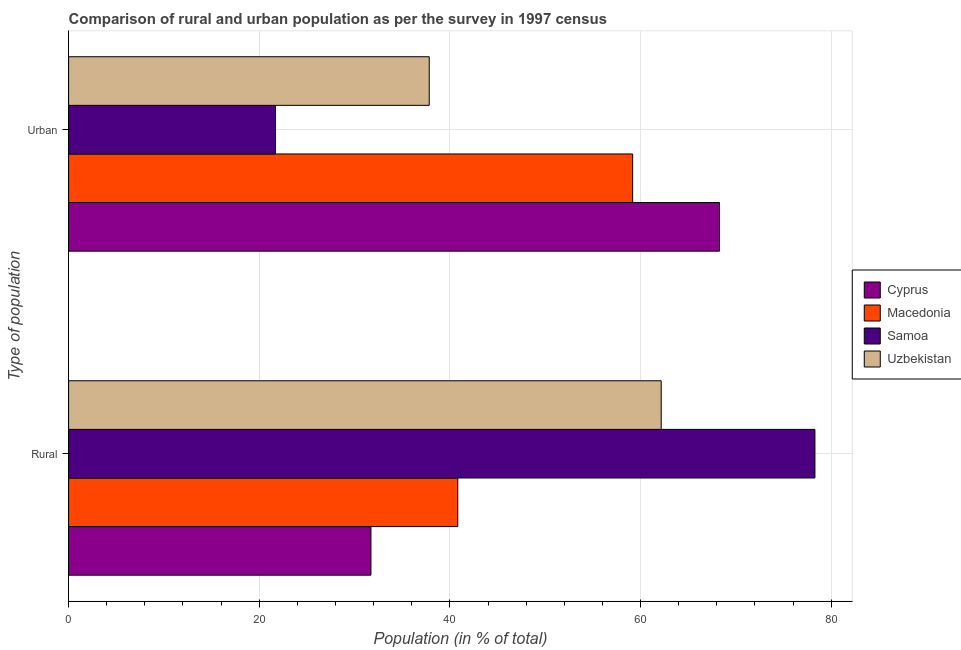How many groups of bars are there?
Keep it short and to the point. 2. What is the label of the 2nd group of bars from the top?
Ensure brevity in your answer.  Rural. What is the urban population in Macedonia?
Offer a terse response. 59.17. Across all countries, what is the maximum urban population?
Ensure brevity in your answer.  68.28. Across all countries, what is the minimum urban population?
Your response must be concise. 21.7. In which country was the urban population maximum?
Provide a short and direct response. Cyprus. In which country was the rural population minimum?
Your response must be concise. Cyprus. What is the total urban population in the graph?
Provide a short and direct response. 186.99. What is the difference between the urban population in Uzbekistan and that in Macedonia?
Give a very brief answer. -21.34. What is the difference between the rural population in Samoa and the urban population in Uzbekistan?
Keep it short and to the point. 40.46. What is the average urban population per country?
Provide a short and direct response. 46.75. What is the difference between the urban population and rural population in Samoa?
Provide a succinct answer. -56.59. In how many countries, is the rural population greater than 68 %?
Make the answer very short. 1. What is the ratio of the rural population in Uzbekistan to that in Samoa?
Your response must be concise. 0.79. What does the 3rd bar from the top in Urban represents?
Your response must be concise. Macedonia. What does the 4th bar from the bottom in Rural represents?
Offer a very short reply. Uzbekistan. How many countries are there in the graph?
Provide a short and direct response. 4. What is the difference between two consecutive major ticks on the X-axis?
Your answer should be very brief. 20. Are the values on the major ticks of X-axis written in scientific E-notation?
Provide a succinct answer. No. Does the graph contain grids?
Offer a terse response. Yes. Where does the legend appear in the graph?
Your response must be concise. Center right. How many legend labels are there?
Your response must be concise. 4. What is the title of the graph?
Ensure brevity in your answer.  Comparison of rural and urban population as per the survey in 1997 census. What is the label or title of the X-axis?
Offer a terse response. Population (in % of total). What is the label or title of the Y-axis?
Offer a very short reply. Type of population. What is the Population (in % of total) in Cyprus in Rural?
Ensure brevity in your answer.  31.72. What is the Population (in % of total) of Macedonia in Rural?
Your response must be concise. 40.83. What is the Population (in % of total) of Samoa in Rural?
Offer a terse response. 78.3. What is the Population (in % of total) in Uzbekistan in Rural?
Make the answer very short. 62.17. What is the Population (in % of total) in Cyprus in Urban?
Provide a succinct answer. 68.28. What is the Population (in % of total) in Macedonia in Urban?
Give a very brief answer. 59.17. What is the Population (in % of total) in Samoa in Urban?
Provide a succinct answer. 21.7. What is the Population (in % of total) in Uzbekistan in Urban?
Provide a short and direct response. 37.83. Across all Type of population, what is the maximum Population (in % of total) in Cyprus?
Your response must be concise. 68.28. Across all Type of population, what is the maximum Population (in % of total) in Macedonia?
Give a very brief answer. 59.17. Across all Type of population, what is the maximum Population (in % of total) of Samoa?
Your response must be concise. 78.3. Across all Type of population, what is the maximum Population (in % of total) of Uzbekistan?
Your answer should be compact. 62.17. Across all Type of population, what is the minimum Population (in % of total) in Cyprus?
Provide a short and direct response. 31.72. Across all Type of population, what is the minimum Population (in % of total) in Macedonia?
Provide a succinct answer. 40.83. Across all Type of population, what is the minimum Population (in % of total) of Samoa?
Your answer should be compact. 21.7. Across all Type of population, what is the minimum Population (in % of total) in Uzbekistan?
Ensure brevity in your answer.  37.83. What is the total Population (in % of total) of Uzbekistan in the graph?
Your answer should be compact. 100. What is the difference between the Population (in % of total) in Cyprus in Rural and that in Urban?
Your answer should be very brief. -36.57. What is the difference between the Population (in % of total) of Macedonia in Rural and that in Urban?
Your answer should be compact. -18.34. What is the difference between the Population (in % of total) in Samoa in Rural and that in Urban?
Your response must be concise. 56.59. What is the difference between the Population (in % of total) in Uzbekistan in Rural and that in Urban?
Provide a succinct answer. 24.33. What is the difference between the Population (in % of total) of Cyprus in Rural and the Population (in % of total) of Macedonia in Urban?
Keep it short and to the point. -27.45. What is the difference between the Population (in % of total) of Cyprus in Rural and the Population (in % of total) of Samoa in Urban?
Give a very brief answer. 10.01. What is the difference between the Population (in % of total) of Cyprus in Rural and the Population (in % of total) of Uzbekistan in Urban?
Make the answer very short. -6.12. What is the difference between the Population (in % of total) in Macedonia in Rural and the Population (in % of total) in Samoa in Urban?
Ensure brevity in your answer.  19.12. What is the difference between the Population (in % of total) in Macedonia in Rural and the Population (in % of total) in Uzbekistan in Urban?
Ensure brevity in your answer.  3. What is the difference between the Population (in % of total) of Samoa in Rural and the Population (in % of total) of Uzbekistan in Urban?
Your response must be concise. 40.46. What is the average Population (in % of total) of Uzbekistan per Type of population?
Make the answer very short. 50. What is the difference between the Population (in % of total) in Cyprus and Population (in % of total) in Macedonia in Rural?
Your answer should be compact. -9.11. What is the difference between the Population (in % of total) in Cyprus and Population (in % of total) in Samoa in Rural?
Provide a short and direct response. -46.58. What is the difference between the Population (in % of total) in Cyprus and Population (in % of total) in Uzbekistan in Rural?
Your answer should be compact. -30.45. What is the difference between the Population (in % of total) of Macedonia and Population (in % of total) of Samoa in Rural?
Your answer should be compact. -37.47. What is the difference between the Population (in % of total) in Macedonia and Population (in % of total) in Uzbekistan in Rural?
Your response must be concise. -21.34. What is the difference between the Population (in % of total) in Samoa and Population (in % of total) in Uzbekistan in Rural?
Offer a terse response. 16.13. What is the difference between the Population (in % of total) of Cyprus and Population (in % of total) of Macedonia in Urban?
Make the answer very short. 9.11. What is the difference between the Population (in % of total) of Cyprus and Population (in % of total) of Samoa in Urban?
Provide a short and direct response. 46.58. What is the difference between the Population (in % of total) in Cyprus and Population (in % of total) in Uzbekistan in Urban?
Offer a very short reply. 30.45. What is the difference between the Population (in % of total) of Macedonia and Population (in % of total) of Samoa in Urban?
Provide a short and direct response. 37.47. What is the difference between the Population (in % of total) in Macedonia and Population (in % of total) in Uzbekistan in Urban?
Offer a terse response. 21.34. What is the difference between the Population (in % of total) in Samoa and Population (in % of total) in Uzbekistan in Urban?
Keep it short and to the point. -16.13. What is the ratio of the Population (in % of total) of Cyprus in Rural to that in Urban?
Ensure brevity in your answer.  0.46. What is the ratio of the Population (in % of total) in Macedonia in Rural to that in Urban?
Provide a short and direct response. 0.69. What is the ratio of the Population (in % of total) in Samoa in Rural to that in Urban?
Your answer should be compact. 3.61. What is the ratio of the Population (in % of total) in Uzbekistan in Rural to that in Urban?
Offer a terse response. 1.64. What is the difference between the highest and the second highest Population (in % of total) in Cyprus?
Your response must be concise. 36.57. What is the difference between the highest and the second highest Population (in % of total) in Macedonia?
Make the answer very short. 18.34. What is the difference between the highest and the second highest Population (in % of total) of Samoa?
Keep it short and to the point. 56.59. What is the difference between the highest and the second highest Population (in % of total) in Uzbekistan?
Give a very brief answer. 24.33. What is the difference between the highest and the lowest Population (in % of total) of Cyprus?
Your response must be concise. 36.57. What is the difference between the highest and the lowest Population (in % of total) of Macedonia?
Ensure brevity in your answer.  18.34. What is the difference between the highest and the lowest Population (in % of total) in Samoa?
Make the answer very short. 56.59. What is the difference between the highest and the lowest Population (in % of total) of Uzbekistan?
Provide a short and direct response. 24.33. 